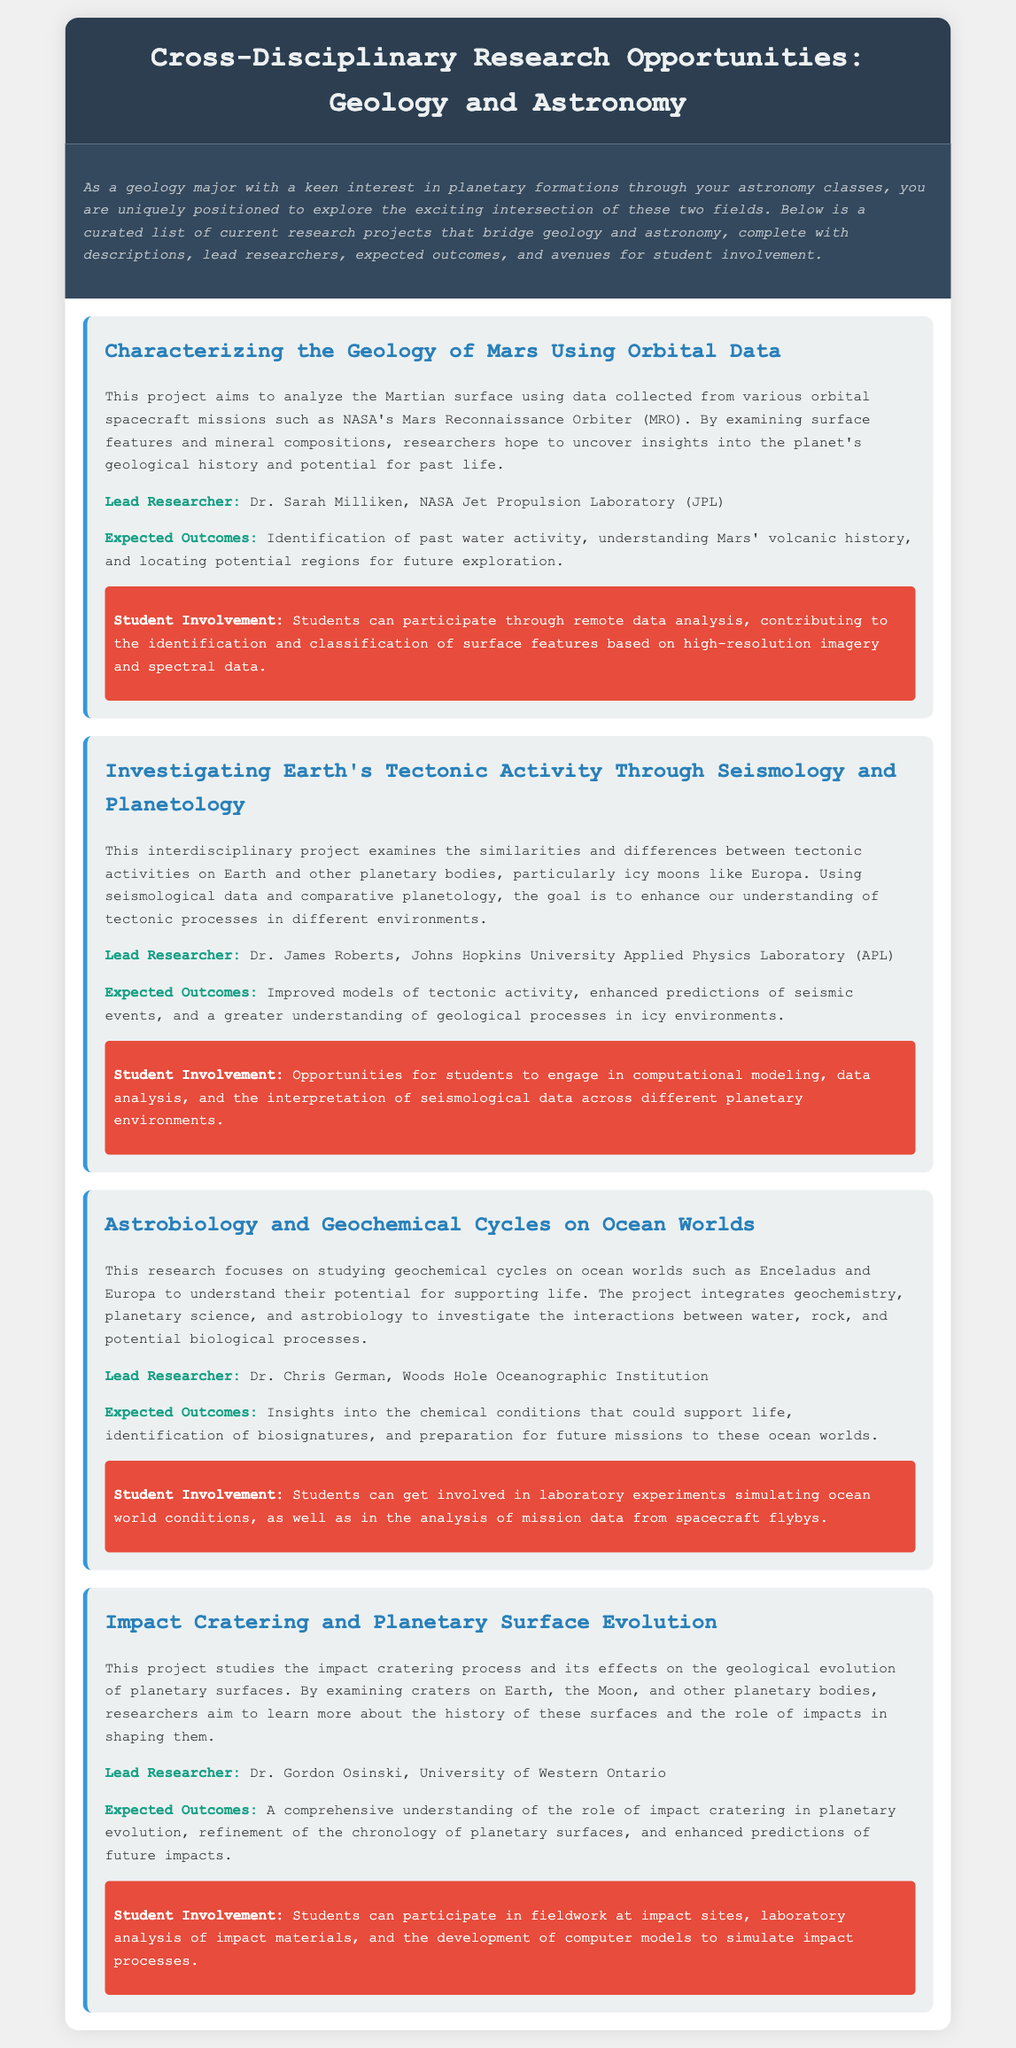What is the title of the first research project? The title of the first research project is listed at the beginning of the project section and is "Characterizing the Geology of Mars Using Orbital Data."
Answer: Characterizing the Geology of Mars Using Orbital Data Who is the lead researcher for the project on Earth's tectonic activity? The document specifies that the lead researcher for the project on Earth's tectonic activity is Dr. James Roberts.
Answer: Dr. James Roberts What expected outcomes are mentioned for the Astrobiology and Geochemical Cycles project? The expected outcomes for the Astrobiology and Geochemical Cycles project are highlighted and include insights into the chemical conditions that could support life.
Answer: Insights into the chemical conditions that could support life How many research projects are detailed in the document? By counting the number of separate project sections within the document, there are a total of four research projects detailed.
Answer: Four What type of student involvement is mentioned for the Impact Cratering project? The student involvement section of the Impact Cratering project discusses participation in fieldwork at impact sites.
Answer: Fieldwork at impact sites What is the primary focus of the project investigating Earth's tectonic activity? The document outlines that the primary focus of this project is to examine similarities and differences between tectonic activities on Earth and other planetary bodies.
Answer: Similarities and differences between tectonic activities What institution is associated with Dr. Chris German? The document indicates that Dr. Chris German is associated with the Woods Hole Oceanographic Institution.
Answer: Woods Hole Oceanographic Institution Which planetary body is primarily studied in the first project? The first project focuses primarily on the planet Mars as indicated in the project description.
Answer: Mars 